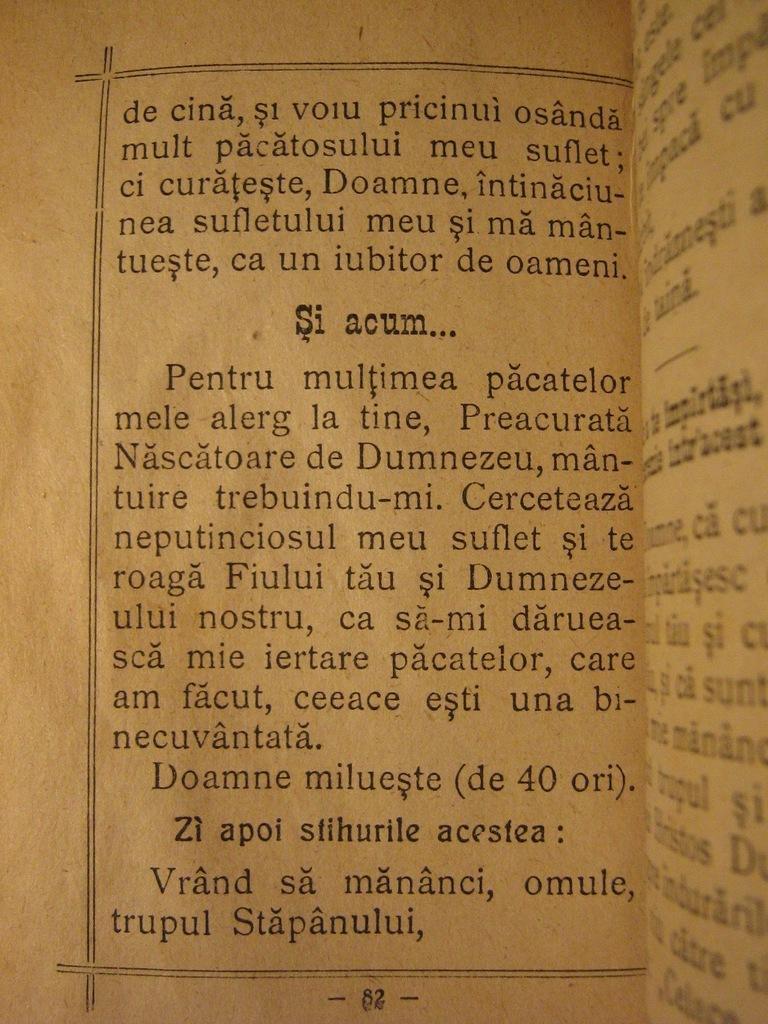Describe this image in one or two sentences. In this image I can see a brown color paper and something is written on it with black color pen. 